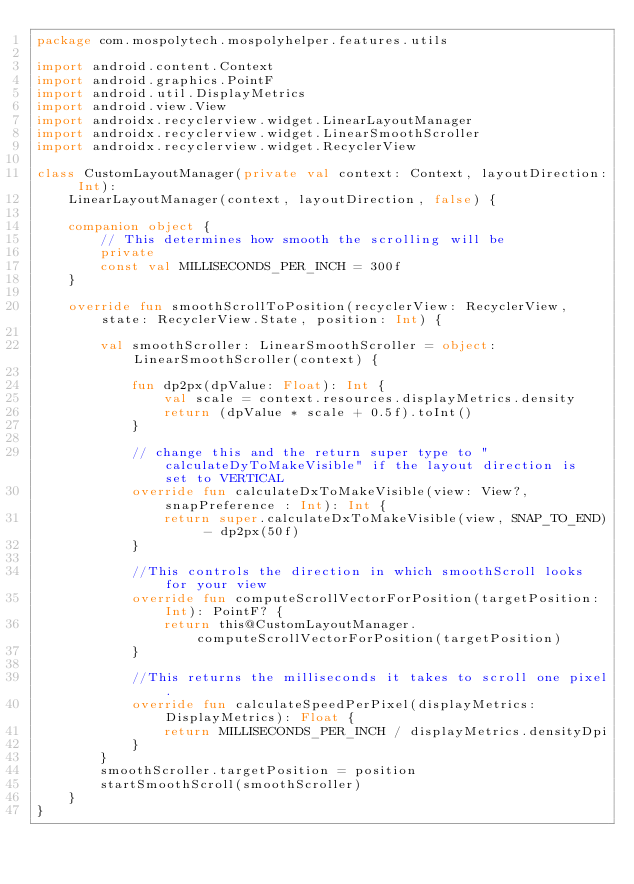<code> <loc_0><loc_0><loc_500><loc_500><_Kotlin_>package com.mospolytech.mospolyhelper.features.utils

import android.content.Context
import android.graphics.PointF
import android.util.DisplayMetrics
import android.view.View
import androidx.recyclerview.widget.LinearLayoutManager
import androidx.recyclerview.widget.LinearSmoothScroller
import androidx.recyclerview.widget.RecyclerView

class CustomLayoutManager(private val context: Context, layoutDirection: Int):
    LinearLayoutManager(context, layoutDirection, false) {

    companion object {
        // This determines how smooth the scrolling will be
        private
        const val MILLISECONDS_PER_INCH = 300f
    }

    override fun smoothScrollToPosition(recyclerView: RecyclerView, state: RecyclerView.State, position: Int) {

        val smoothScroller: LinearSmoothScroller = object: LinearSmoothScroller(context) {

            fun dp2px(dpValue: Float): Int {
                val scale = context.resources.displayMetrics.density
                return (dpValue * scale + 0.5f).toInt()
            }

            // change this and the return super type to "calculateDyToMakeVisible" if the layout direction is set to VERTICAL
            override fun calculateDxToMakeVisible(view: View?, snapPreference : Int): Int {
                return super.calculateDxToMakeVisible(view, SNAP_TO_END) - dp2px(50f)
            }

            //This controls the direction in which smoothScroll looks for your view
            override fun computeScrollVectorForPosition(targetPosition: Int): PointF? {
                return this@CustomLayoutManager.computeScrollVectorForPosition(targetPosition)
            }

            //This returns the milliseconds it takes to scroll one pixel.
            override fun calculateSpeedPerPixel(displayMetrics: DisplayMetrics): Float {
                return MILLISECONDS_PER_INCH / displayMetrics.densityDpi
            }
        }
        smoothScroller.targetPosition = position
        startSmoothScroll(smoothScroller)
    }
}</code> 